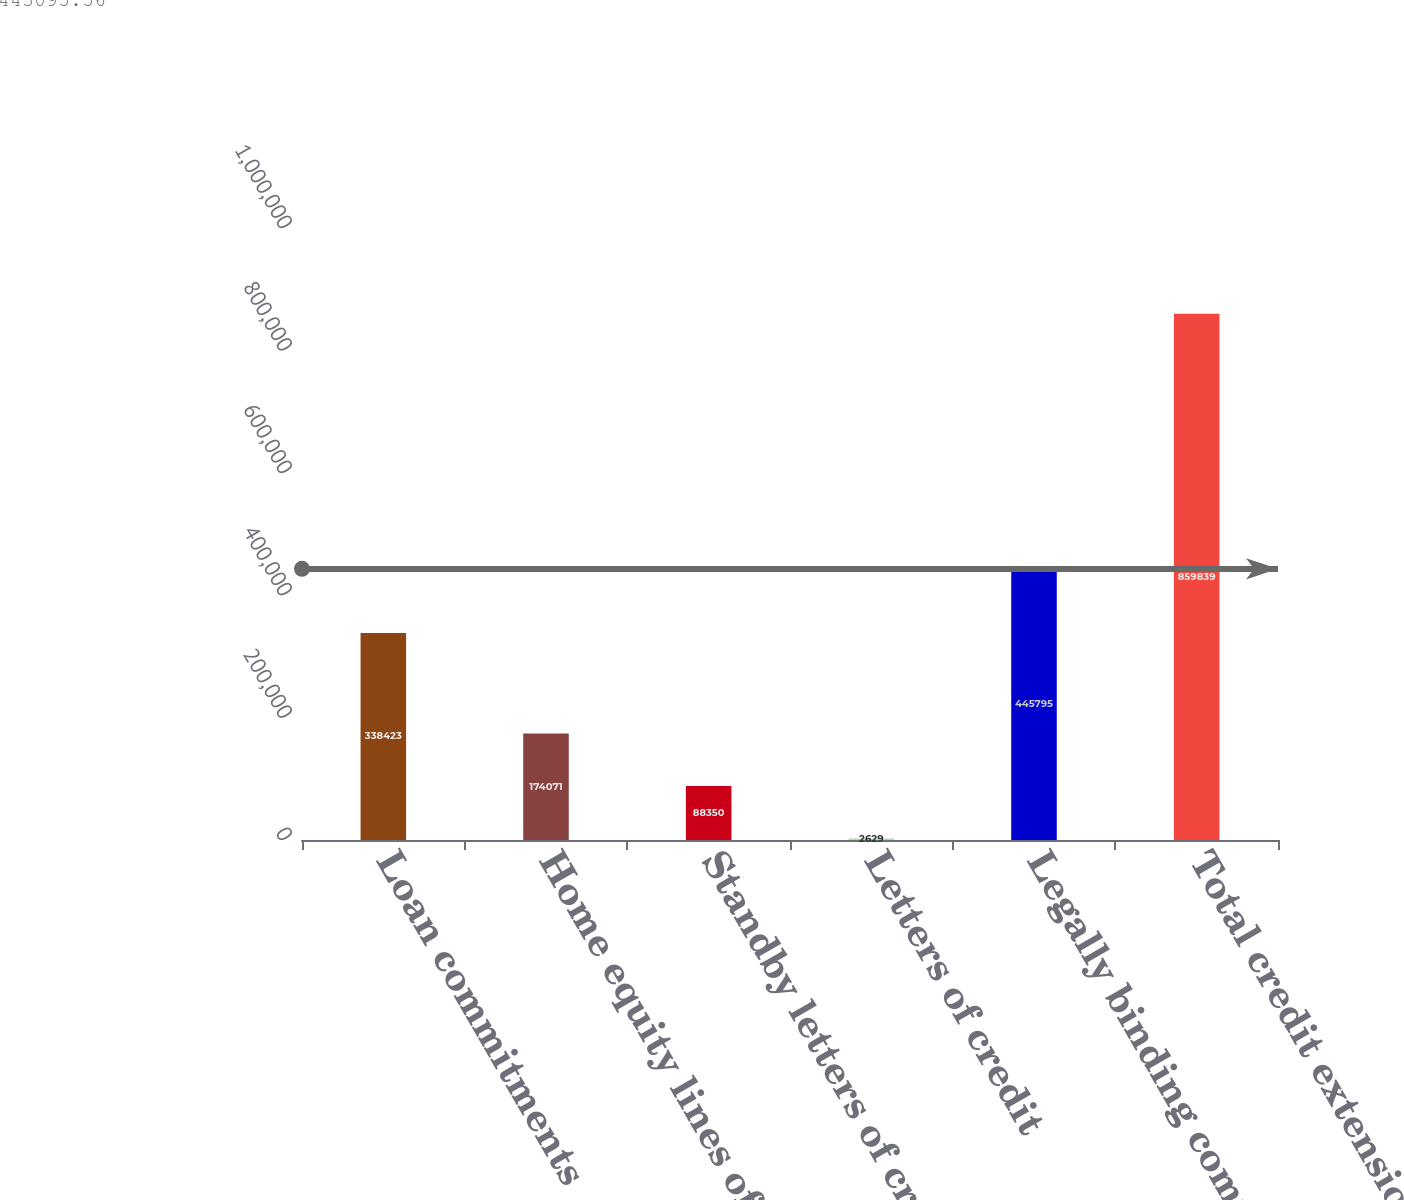Convert chart. <chart><loc_0><loc_0><loc_500><loc_500><bar_chart><fcel>Loan commitments<fcel>Home equity lines of credit<fcel>Standby letters of credit and<fcel>Letters of credit<fcel>Legally binding commitments<fcel>Total credit extension<nl><fcel>338423<fcel>174071<fcel>88350<fcel>2629<fcel>445795<fcel>859839<nl></chart> 